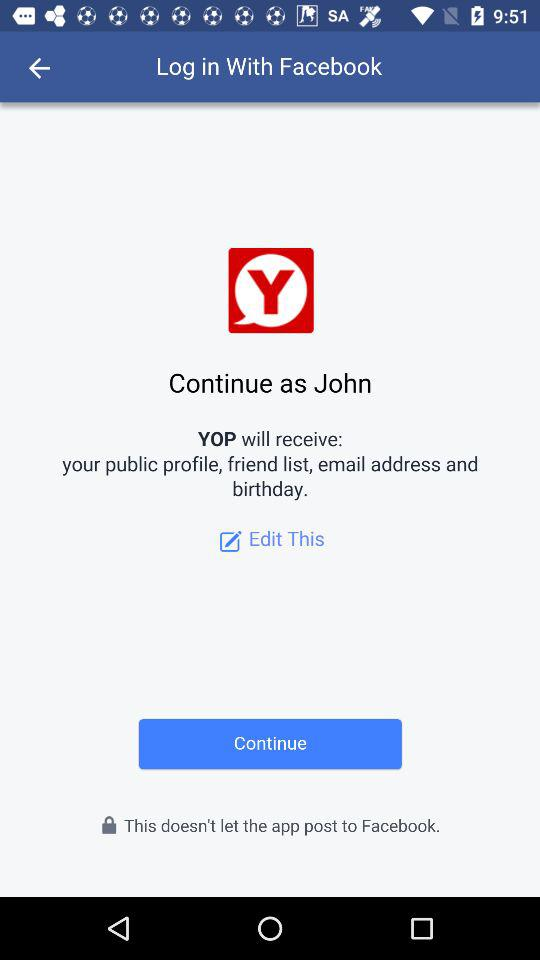What is the name of the user? The name of the user is John. 